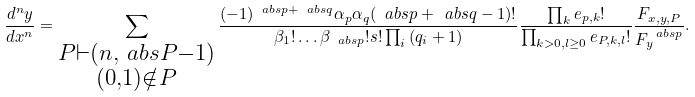Convert formula to latex. <formula><loc_0><loc_0><loc_500><loc_500>\frac { d ^ { n } y } { d x ^ { n } } = \sum _ { \substack { P \vdash ( n , \ a b s { P } - 1 ) \\ ( 0 , 1 ) \notin P } } \frac { ( - 1 ) ^ { \ a b s { p } + \ a b s { q } } \alpha _ { p } \alpha _ { q } ( \ a b s { p } + \ a b s { q } - 1 ) ! } { \beta _ { 1 } ! \dots \beta _ { \ a b s { p } } ! s ! \prod _ { i } { ( q _ { i } + 1 ) } } \frac { \prod _ { k } e _ { p , k } ! } { \prod _ { k > 0 , l \geq 0 } e _ { P , k , l } ! } \frac { F _ { x , y , P } } { F _ { y } ^ { \ a b s p } } .</formula> 